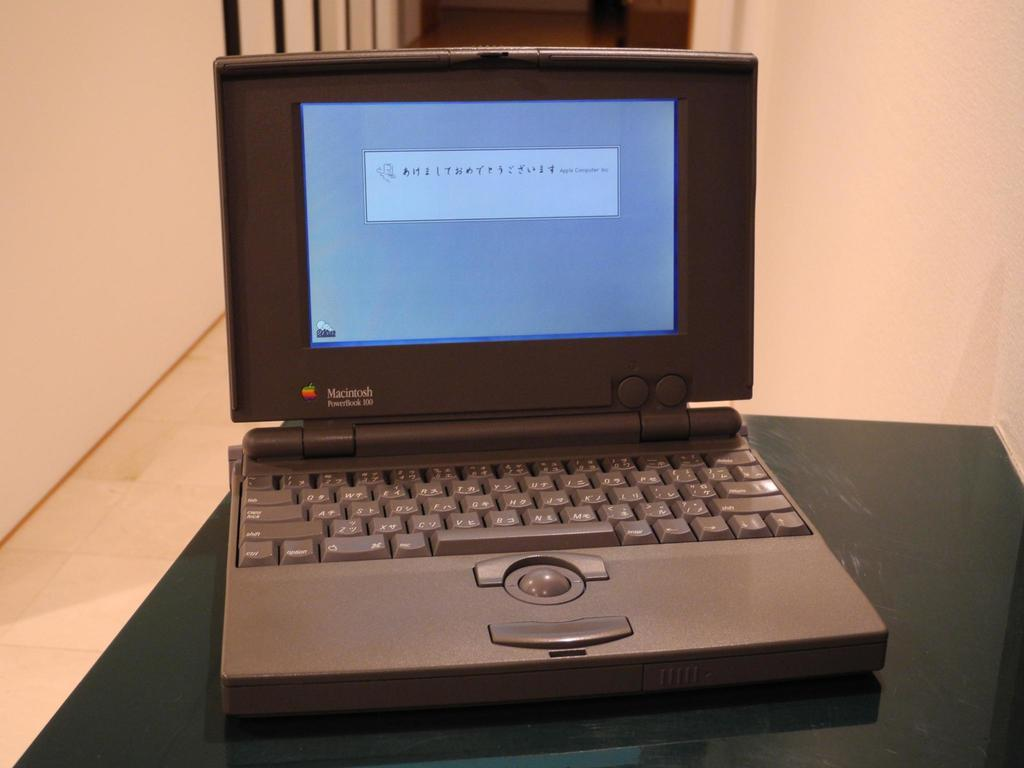<image>
Describe the image concisely. A black laptop with Macintosh written on the monitor. 